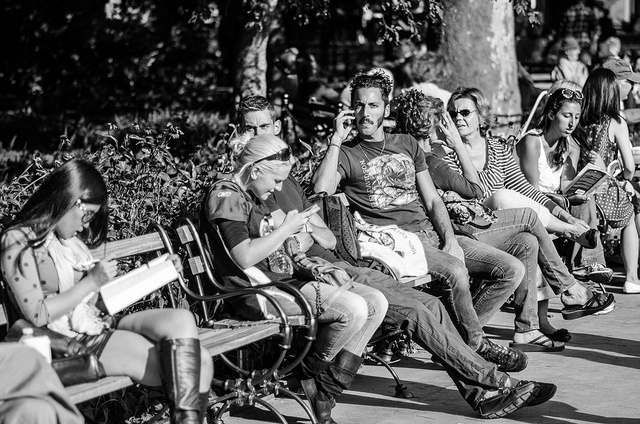Describe the objects in this image and their specific colors. I can see people in black, darkgray, lightgray, and gray tones, people in black, darkgray, lightgray, and gray tones, people in black, darkgray, gray, and lightgray tones, people in black, darkgray, gray, and lightgray tones, and bench in black, darkgray, gray, and lightgray tones in this image. 